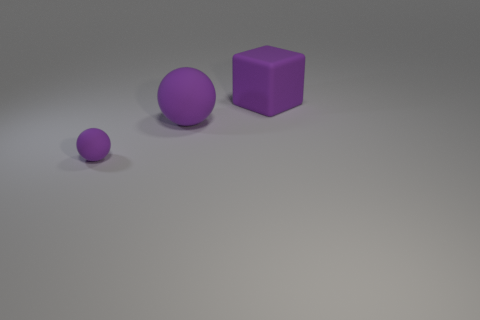There is a rubber object that is right of the tiny rubber thing and left of the purple block; what color is it? The object situated to the right of the tiny rubber thing and to the left of the purple block is also purple, featuring a slightly muted shade of the color with a matte finish. 